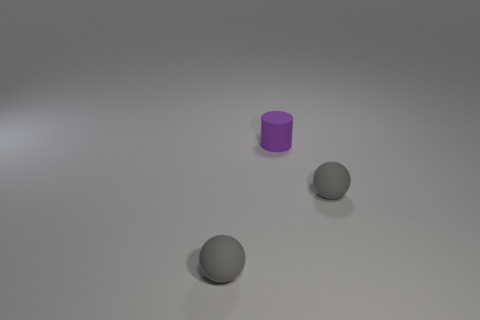Add 1 tiny green rubber cubes. How many objects exist? 4 Subtract all spheres. How many objects are left? 1 Subtract all small matte objects. Subtract all small blue metal cylinders. How many objects are left? 0 Add 1 purple rubber cylinders. How many purple rubber cylinders are left? 2 Add 2 small purple things. How many small purple things exist? 3 Subtract 0 green balls. How many objects are left? 3 